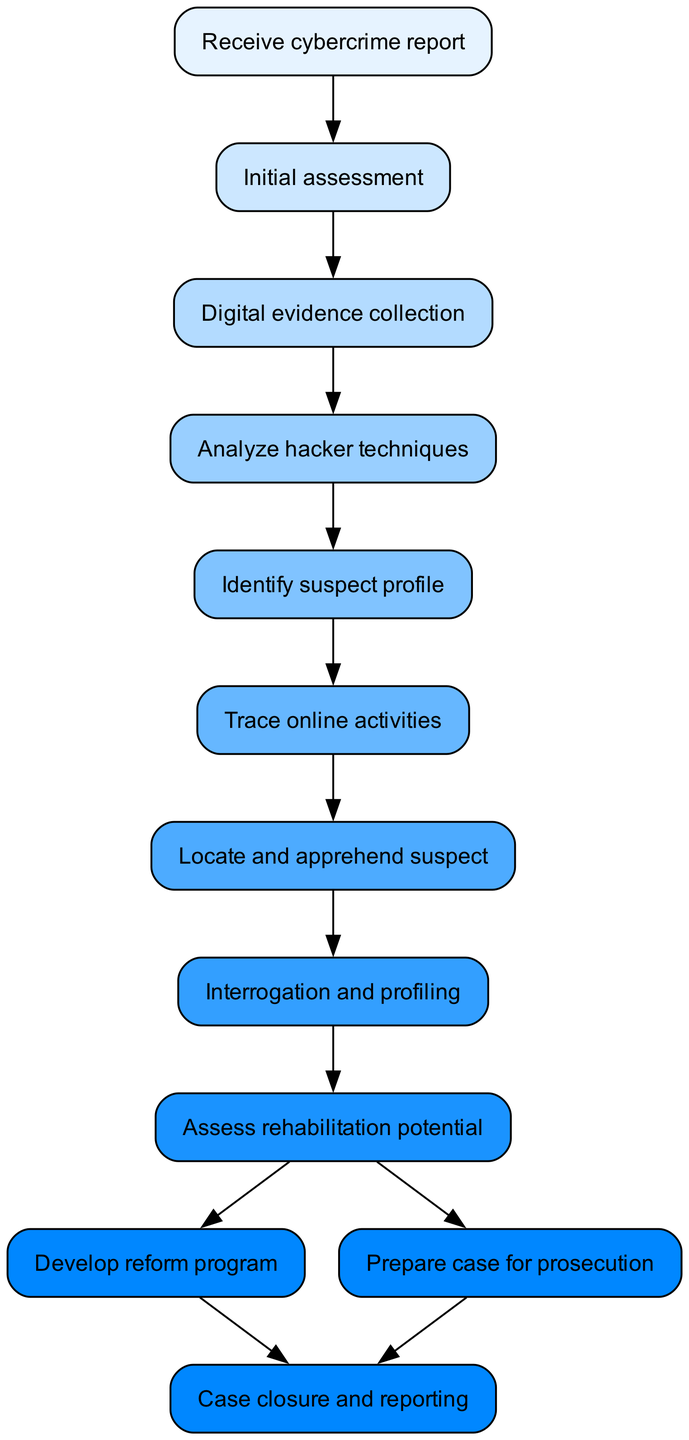What is the first step in the process? The first step in the process is clearly labeled in the diagram as "Receive cybercrime report." This is the starting point of the flow chart and is positioned at the very top.
Answer: Receive cybercrime report How many steps are there in total? By counting each distinct node from the start to the finish, we can see that there are 11 steps in total, including the initial report and the case closure.
Answer: 11 What is the final node of the diagram? The final node, representing the conclusion of the process, is labeled "Case closure and reporting." This indicates where the investigation concludes, indicating the end of the flowchart.
Answer: Case closure and reporting What step comes immediately after "Interrogation and profiling"? The step that follows "Interrogation and profiling" is "Assess rehabilitation potential." This is indicated by the direct link in the flow chart from one step to the next.
Answer: Assess rehabilitation potential Which steps lead to the development of a reform program? After assessing rehabilitation potential, there is a direct decision point leading to two possible outcomes: "Develop reform program" or "Prepare case for prosecution." Therefore, both routes stem from the same evaluation step.
Answer: Develop reform program and Prepare case for prosecution How many different outcomes are possible after the "Assess rehabilitation potential" step? There are two different outcomes possible after this step, as indicated by the branching paths leading either to "Develop reform program" or "Prepare case for prosecution."
Answer: 2 Which step comes before "Analyze hacker techniques"? Before "Analyze hacker techniques," the preceding step is "Digital evidence collection." This is a sequential step that signifies the process of gathering necessary information.
Answer: Digital evidence collection What color is the node for "Identify suspect profile"? The node labeled "Identify suspect profile" is colored consistent with the flowchart’s color palette; it appears in the sixth position, corresponding to the color assigned for that step, which is a light blue shade.
Answer: Light blue 